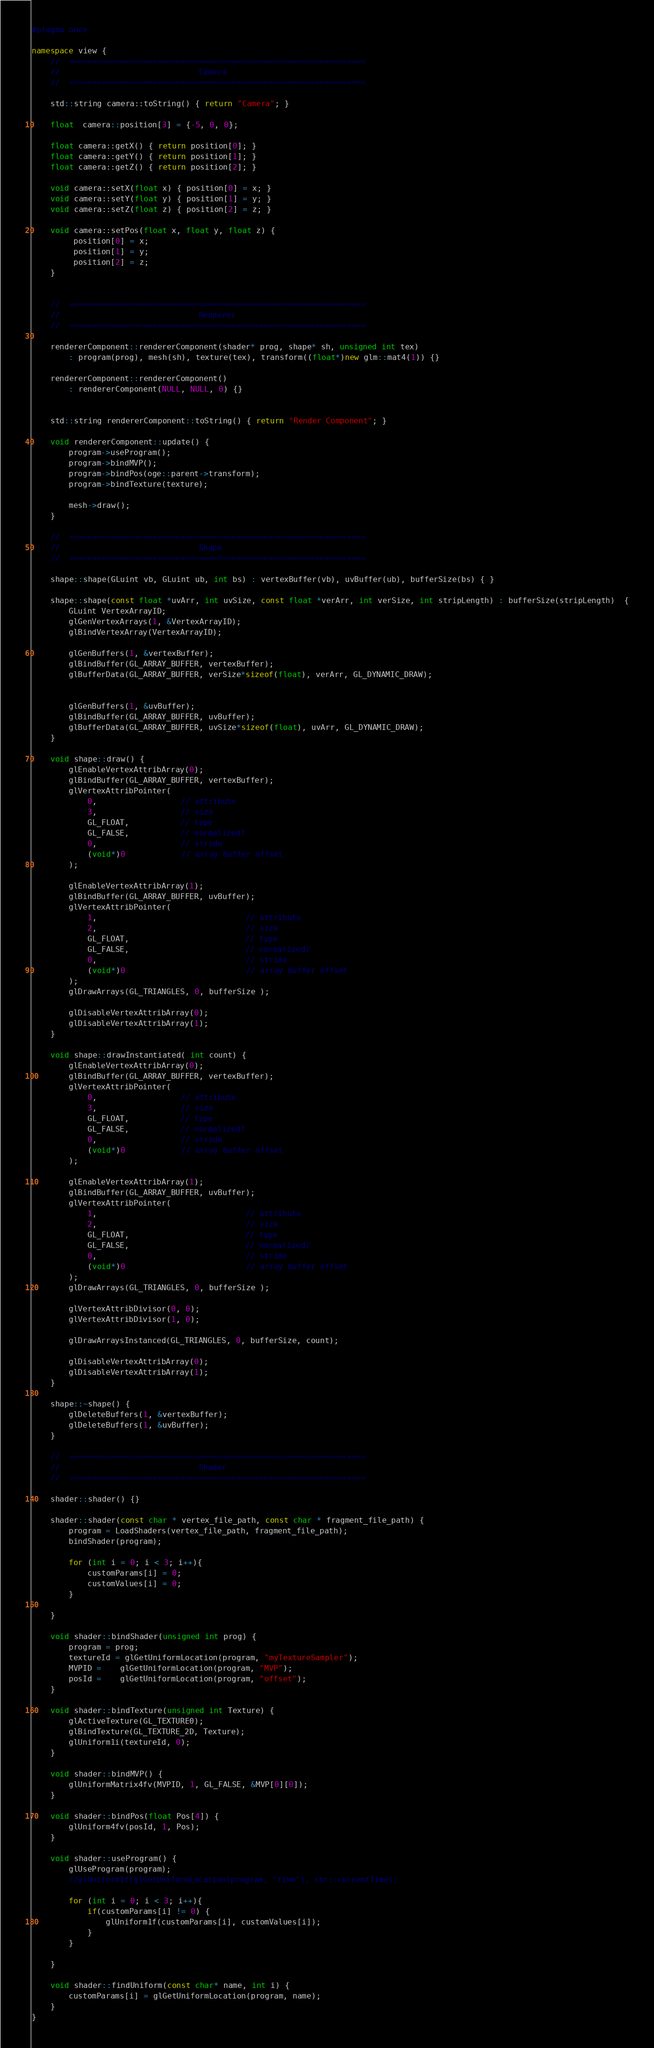<code> <loc_0><loc_0><loc_500><loc_500><_C++_>#pragma once

namespace view {
	//	================================================================
	//								Camera
	//  ================================================================
	
	std::string camera::toString() { return "Camera"; }
	
	float  camera::position[3] = {-5, 0, 0};
	
	float camera::getX() { return position[0]; }
	float camera::getY() { return position[1]; }
	float camera::getZ() { return position[2]; }
	
	void camera::setX(float x) { position[0] = x; }
	void camera::setY(float y) { position[1] = y; }
	void camera::setZ(float z) { position[2] = z; }
	
	void camera::setPos(float x, float y, float z) {
		 position[0] = x;
		 position[1] = y;
		 position[2] = z;
	}
	
	
	//	================================================================
	//								Renderer
	//  ================================================================
	
	rendererComponent::rendererComponent(shader* prog, shape* sh, unsigned int tex)
		: program(prog), mesh(sh), texture(tex), transform((float*)new glm::mat4(1)) {}
		
	rendererComponent::rendererComponent() 
		: rendererComponent(NULL, NULL, 0) {} 
	

	std::string rendererComponent::toString() { return "Render Component"; }
	
	void rendererComponent::update() {
		program->useProgram();
		program->bindMVP();
		program->bindPos(oge::parent->transform);
		program->bindTexture(texture);
		
		mesh->draw();
	}

	//	================================================================
	//								Shape
	//  ================================================================
	
	shape::shape(GLuint vb, GLuint ub, int bs) : vertexBuffer(vb), uvBuffer(ub), bufferSize(bs) { }
	
	shape::shape(const float *uvArr, int uvSize, const float *verArr, int verSize, int stripLength) : bufferSize(stripLength)  {
		GLuint VertexArrayID;
		glGenVertexArrays(1, &VertexArrayID);
		glBindVertexArray(VertexArrayID);		
		
		glGenBuffers(1, &vertexBuffer);
		glBindBuffer(GL_ARRAY_BUFFER, vertexBuffer);
		glBufferData(GL_ARRAY_BUFFER, verSize*sizeof(float), verArr, GL_DYNAMIC_DRAW);

		
		glGenBuffers(1, &uvBuffer);
		glBindBuffer(GL_ARRAY_BUFFER, uvBuffer);
		glBufferData(GL_ARRAY_BUFFER, uvSize*sizeof(float), uvArr, GL_DYNAMIC_DRAW);
	}
	
	void shape::draw() {
		glEnableVertexAttribArray(0);
		glBindBuffer(GL_ARRAY_BUFFER, vertexBuffer);
		glVertexAttribPointer(
			0,                  // attribute
			3,                  // size
			GL_FLOAT,           // type
			GL_FALSE,           // normalized?
			0,                  // stride
			(void*)0            // array buffer offset
		);

		glEnableVertexAttribArray(1);
		glBindBuffer(GL_ARRAY_BUFFER, uvBuffer);
		glVertexAttribPointer(
			1,                                // attribute
			2,                                // size
			GL_FLOAT,                         // type
			GL_FALSE,                         // normalized?
			0,                                // stride
			(void*)0                          // array buffer offset
		);
		glDrawArrays(GL_TRIANGLES, 0, bufferSize );
		
		glDisableVertexAttribArray(0);
		glDisableVertexAttribArray(1);
	}
	
	void shape::drawInstantiated( int count) {
		glEnableVertexAttribArray(0);
		glBindBuffer(GL_ARRAY_BUFFER, vertexBuffer);
		glVertexAttribPointer(
			0,                  // attribute
			3,                  // size
			GL_FLOAT,           // type
			GL_FALSE,           // normalized?
			0,                  // stride
			(void*)0            // array buffer offset
		);

		glEnableVertexAttribArray(1);
		glBindBuffer(GL_ARRAY_BUFFER, uvBuffer);
		glVertexAttribPointer(
			1,                                // attribute
			2,                                // size
			GL_FLOAT,                         // type
			GL_FALSE,                         // normalized?
			0,                                // stride
			(void*)0                          // array buffer offset
		);
		glDrawArrays(GL_TRIANGLES, 0, bufferSize );
		
		glVertexAttribDivisor(0, 0);
		glVertexAttribDivisor(1, 0); 
		
		glDrawArraysInstanced(GL_TRIANGLES, 0, bufferSize, count);
		
		glDisableVertexAttribArray(0);
		glDisableVertexAttribArray(1);
	}
	
	shape::~shape() {
		glDeleteBuffers(1, &vertexBuffer);
		glDeleteBuffers(1, &uvBuffer);
	}
	
	//	================================================================
	//								Shader
	//  ================================================================
	
	shader::shader() {}
	
	shader::shader(const char * vertex_file_path, const char * fragment_file_path) {
		program = LoadShaders(vertex_file_path, fragment_file_path);
		bindShader(program);
		
		for (int i = 0; i < 3; i++){
			customParams[i] = 0;
			customValues[i] = 0;
		}
		
	}
		
	void shader::bindShader(unsigned int prog) {
		program = prog;
		textureId = glGetUniformLocation(program, "myTextureSampler");
		MVPID = 	glGetUniformLocation(program, "MVP");
		posId = 	glGetUniformLocation(program, "offset");
	}
	
	void shader::bindTexture(unsigned int Texture) {
		glActiveTexture(GL_TEXTURE0);
		glBindTexture(GL_TEXTURE_2D, Texture);
		glUniform1i(textureId, 0);
	}
	
	void shader::bindMVP() {
		glUniformMatrix4fv(MVPID, 1, GL_FALSE, &MVP[0][0]);
	}
	
	void shader::bindPos(float Pos[4]) {
		glUniform4fv(posId, 1, Pos);
	}
	
	void shader::useProgram() {
		glUseProgram(program); 
		//glUniform1f(glGetUniformLocation(program, "time"), chr::currentTime);
		
		for (int i = 0; i < 3; i++){
			if(customParams[i] != 0) {
				glUniform1f(customParams[i], customValues[i]);
			}
		}
		
	}
	
	void shader::findUniform(const char* name, int i) {
		customParams[i] = glGetUniformLocation(program, name);
	}
}
</code> 